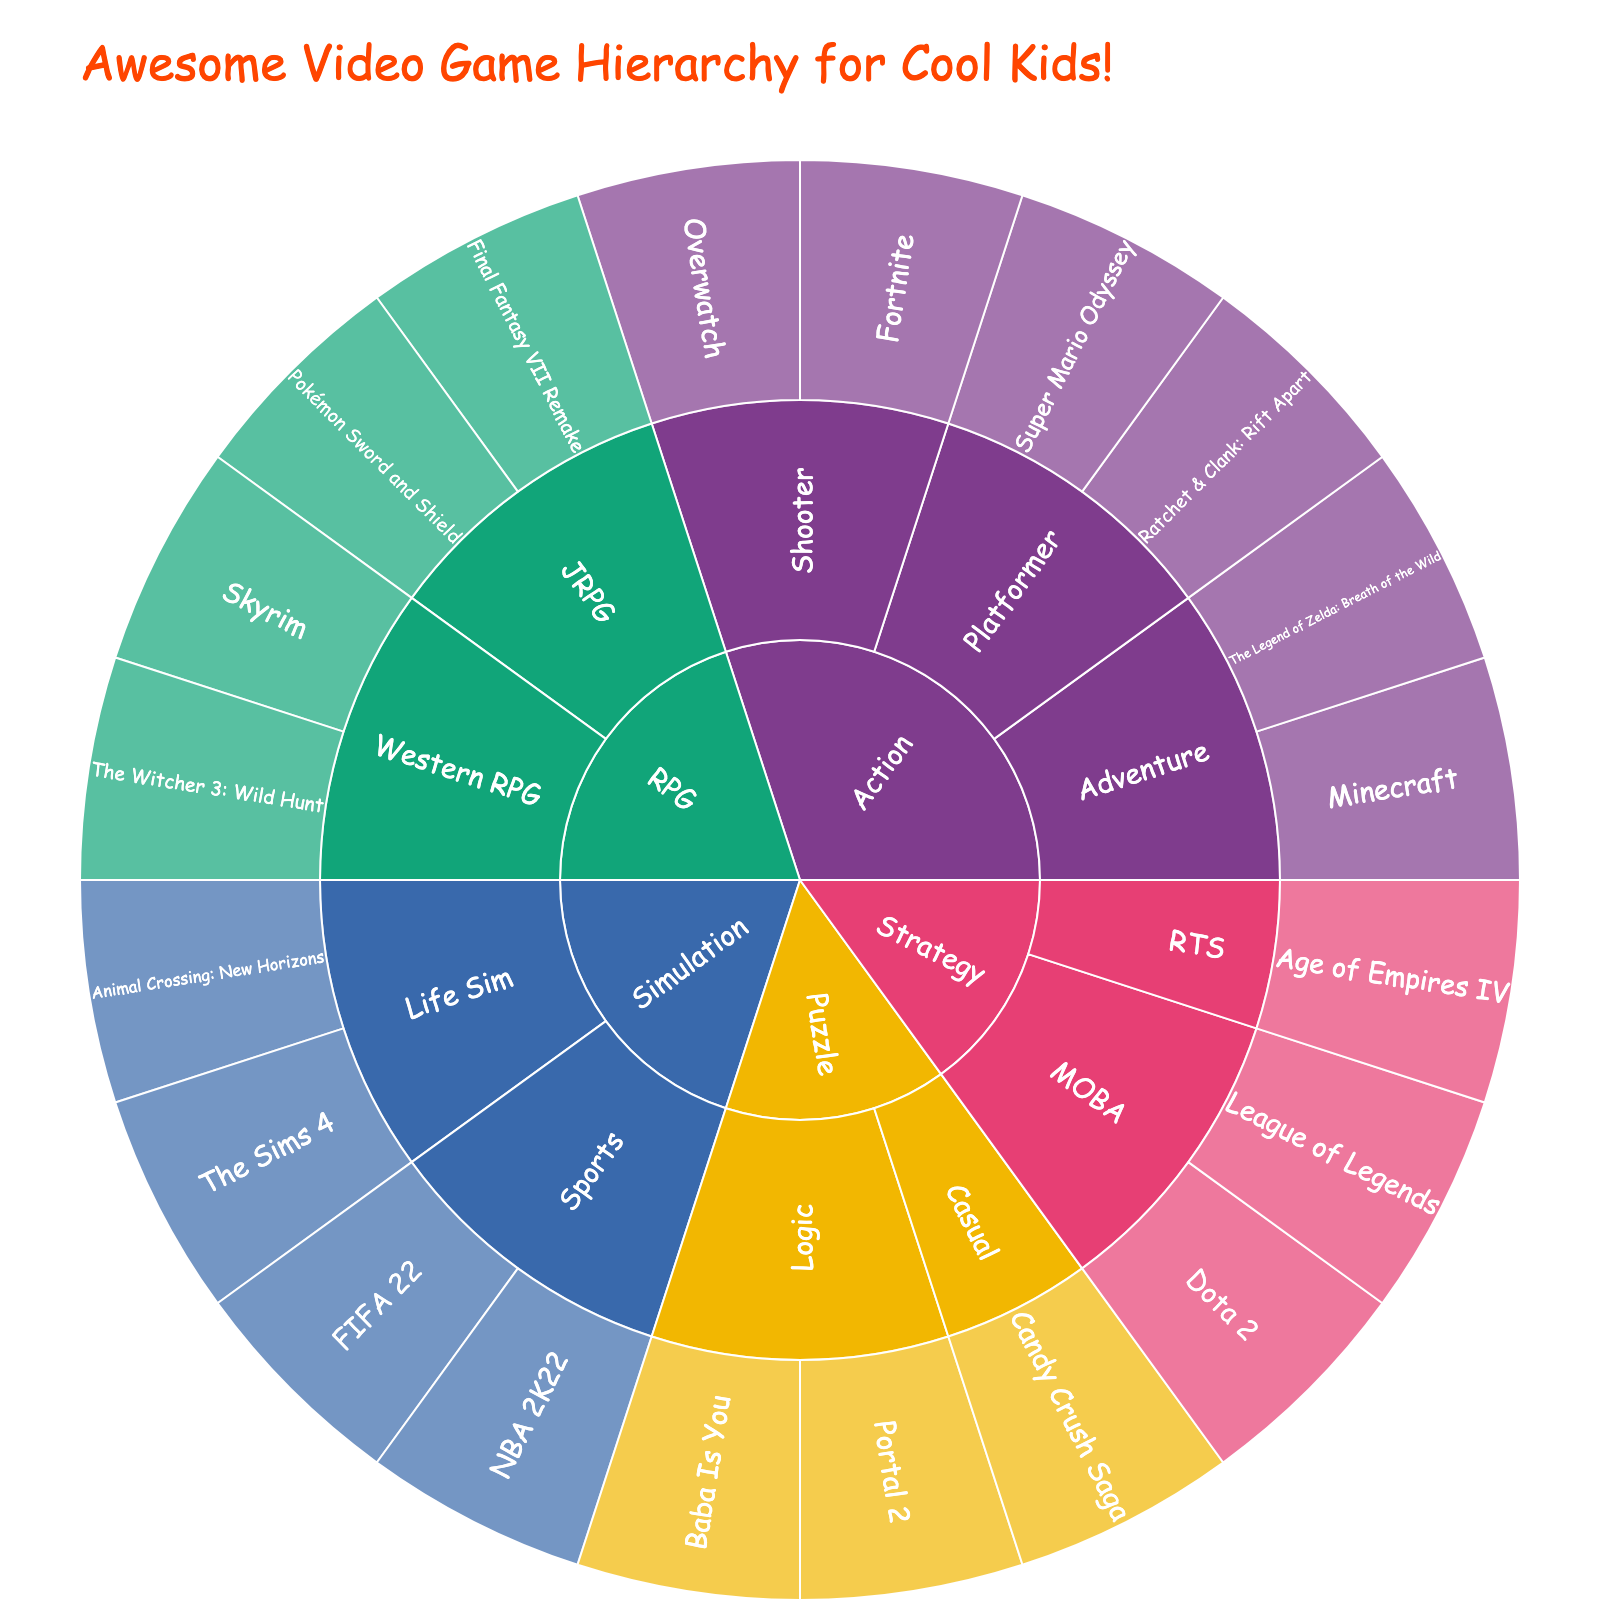What is the title of the sunburst plot? The title is shown at the top of the plot in a large font size. It helps describe what the plot is about and sets the context.
Answer: Awesome Video Game Hierarchy for Cool Kids! Which genre has the most subgenres? Count the number of subgenres for each main genre. Look for the genre with the most divisions stemming from it.
Answer: Action How many games are categorized under RPG? Locate the RPG section of the plot and count how many games are mentioned under this genre.
Answer: 4 Which game belongs to the Puzzle genre and Logic subgenre? Navigate the Puzzle genre's segment and then check within the Logic subgenre segment for the listed games.
Answer: Portal 2 and Baba Is You Between the genres Strategy and Simulation, which has more games in total? Count the total games listed under each genre, including all their subgenres, and compare the totals.
Answer: Simulation What is the proportion of Action games compared to the total number of games? First, count the total number of games. Then, count the number of games in the Action genre. Divide the number of Action games by the total number of games and multiply by 100 to get the percentage.
Answer: 6 out of 20, 30% Are there any more games under the Subgenre MOBA or Subgenre RTS in the Strategy genre? Identify the number of games under each subgenre within the Strategy genre and compare.
Answer: MOBA Which subgenre in the Simulation genre has an equal number of games? Observe the Simulation genre's subgenres and count the games in each subgenre. Locate any subgenres that have the same count.
Answer: Life Sim and Sports What game features Minecraft in the sunburst plot? Look for the Action genre, then follow it to the Adventure subgenre, to find Minecraft.
Answer: Minecraft 